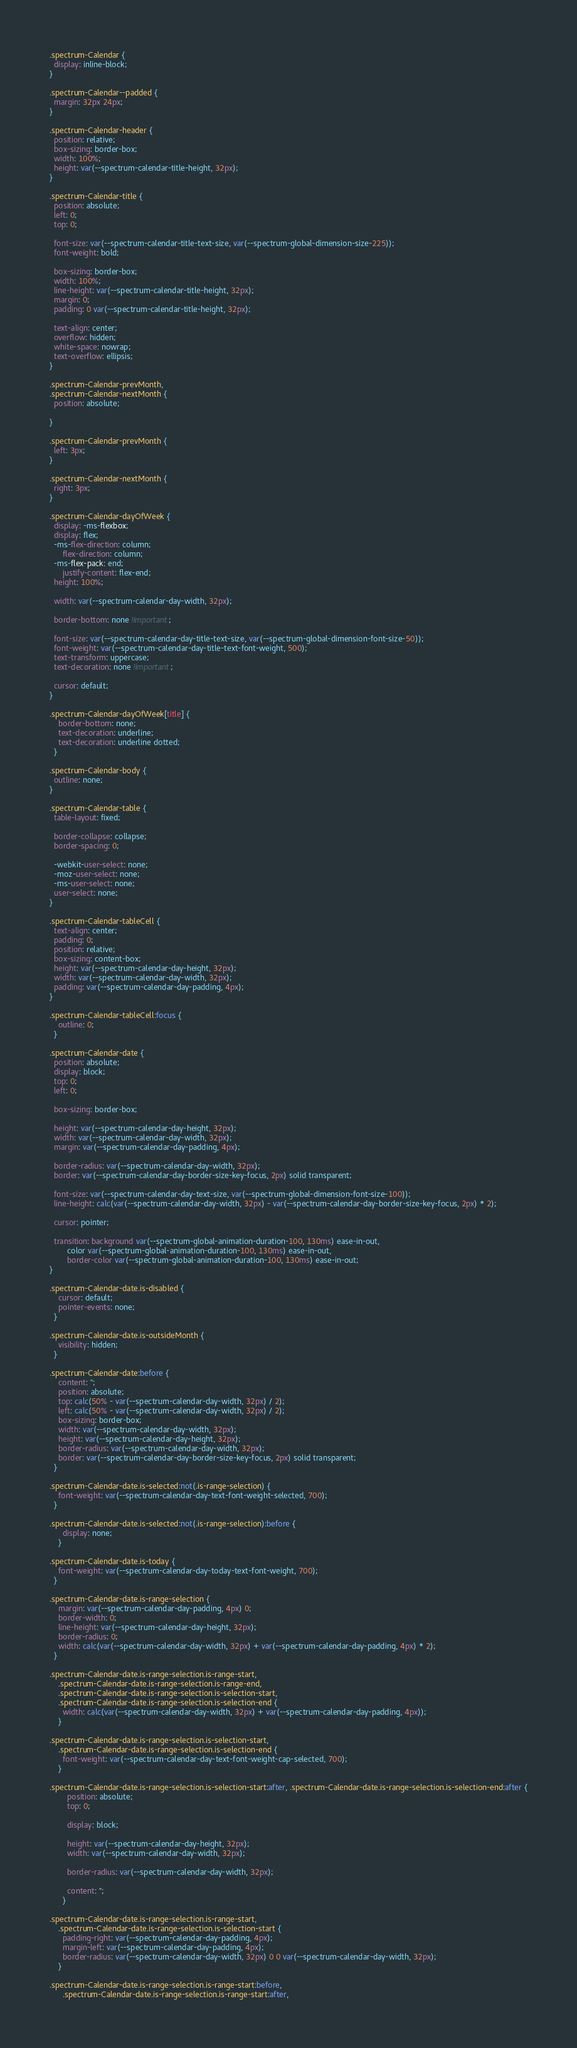<code> <loc_0><loc_0><loc_500><loc_500><_CSS_>.spectrum-Calendar {
  display: inline-block;
}

.spectrum-Calendar--padded {
  margin: 32px 24px;
}

.spectrum-Calendar-header {
  position: relative;
  box-sizing: border-box;
  width: 100%;
  height: var(--spectrum-calendar-title-height, 32px);
}

.spectrum-Calendar-title {
  position: absolute;
  left: 0;
  top: 0;

  font-size: var(--spectrum-calendar-title-text-size, var(--spectrum-global-dimension-size-225));
  font-weight: bold;

  box-sizing: border-box;
  width: 100%;
  line-height: var(--spectrum-calendar-title-height, 32px);
  margin: 0;
  padding: 0 var(--spectrum-calendar-title-height, 32px);

  text-align: center;
  overflow: hidden;
  white-space: nowrap;
  text-overflow: ellipsis;
}

.spectrum-Calendar-prevMonth,
.spectrum-Calendar-nextMonth {
  position: absolute;

}

.spectrum-Calendar-prevMonth {
  left: 3px;
}

.spectrum-Calendar-nextMonth {
  right: 3px;
}

.spectrum-Calendar-dayOfWeek {
  display: -ms-flexbox;
  display: flex;
  -ms-flex-direction: column;
      flex-direction: column;
  -ms-flex-pack: end;
      justify-content: flex-end;
  height: 100%;

  width: var(--spectrum-calendar-day-width, 32px);

  border-bottom: none !important;

  font-size: var(--spectrum-calendar-day-title-text-size, var(--spectrum-global-dimension-font-size-50));
  font-weight: var(--spectrum-calendar-day-title-text-font-weight, 500);
  text-transform: uppercase;
  text-decoration: none !important;

  cursor: default;
}

.spectrum-Calendar-dayOfWeek[title] {
    border-bottom: none;
    text-decoration: underline;
    text-decoration: underline dotted;
  }

.spectrum-Calendar-body {
  outline: none;
}

.spectrum-Calendar-table {
  table-layout: fixed;

  border-collapse: collapse;
  border-spacing: 0;

  -webkit-user-select: none;
  -moz-user-select: none;
  -ms-user-select: none;
  user-select: none;
}

.spectrum-Calendar-tableCell {
  text-align: center;
  padding: 0;
  position: relative;
  box-sizing: content-box;
  height: var(--spectrum-calendar-day-height, 32px);
  width: var(--spectrum-calendar-day-width, 32px);
  padding: var(--spectrum-calendar-day-padding, 4px);
}

.spectrum-Calendar-tableCell:focus {
    outline: 0;
  }

.spectrum-Calendar-date {
  position: absolute;
  display: block;
  top: 0;
  left: 0;

  box-sizing: border-box;

  height: var(--spectrum-calendar-day-height, 32px);
  width: var(--spectrum-calendar-day-width, 32px);
  margin: var(--spectrum-calendar-day-padding, 4px);

  border-radius: var(--spectrum-calendar-day-width, 32px);
  border: var(--spectrum-calendar-day-border-size-key-focus, 2px) solid transparent;

  font-size: var(--spectrum-calendar-day-text-size, var(--spectrum-global-dimension-font-size-100));
  line-height: calc(var(--spectrum-calendar-day-width, 32px) - var(--spectrum-calendar-day-border-size-key-focus, 2px) * 2);

  cursor: pointer;

  transition: background var(--spectrum-global-animation-duration-100, 130ms) ease-in-out,
        color var(--spectrum-global-animation-duration-100, 130ms) ease-in-out,
        border-color var(--spectrum-global-animation-duration-100, 130ms) ease-in-out;
}

.spectrum-Calendar-date.is-disabled {
    cursor: default;
    pointer-events: none;
  }

.spectrum-Calendar-date.is-outsideMonth {
    visibility: hidden;
  }

.spectrum-Calendar-date:before {
    content: '';
    position: absolute;
    top: calc(50% - var(--spectrum-calendar-day-width, 32px) / 2);
    left: calc(50% - var(--spectrum-calendar-day-width, 32px) / 2);
    box-sizing: border-box;
    width: var(--spectrum-calendar-day-width, 32px);
    height: var(--spectrum-calendar-day-height, 32px);
    border-radius: var(--spectrum-calendar-day-width, 32px);
    border: var(--spectrum-calendar-day-border-size-key-focus, 2px) solid transparent;
  }

.spectrum-Calendar-date.is-selected:not(.is-range-selection) {
    font-weight: var(--spectrum-calendar-day-text-font-weight-selected, 700);
  }

.spectrum-Calendar-date.is-selected:not(.is-range-selection):before {
      display: none;
    }

.spectrum-Calendar-date.is-today {
    font-weight: var(--spectrum-calendar-day-today-text-font-weight, 700);
  }

.spectrum-Calendar-date.is-range-selection {
    margin: var(--spectrum-calendar-day-padding, 4px) 0;
    border-width: 0;
    line-height: var(--spectrum-calendar-day-height, 32px);
    border-radius: 0;
    width: calc(var(--spectrum-calendar-day-width, 32px) + var(--spectrum-calendar-day-padding, 4px) * 2);
  }

.spectrum-Calendar-date.is-range-selection.is-range-start,
    .spectrum-Calendar-date.is-range-selection.is-range-end,
    .spectrum-Calendar-date.is-range-selection.is-selection-start,
    .spectrum-Calendar-date.is-range-selection.is-selection-end {
      width: calc(var(--spectrum-calendar-day-width, 32px) + var(--spectrum-calendar-day-padding, 4px));
    }

.spectrum-Calendar-date.is-range-selection.is-selection-start,
    .spectrum-Calendar-date.is-range-selection.is-selection-end {
      font-weight: var(--spectrum-calendar-day-text-font-weight-cap-selected, 700);
    }

.spectrum-Calendar-date.is-range-selection.is-selection-start:after, .spectrum-Calendar-date.is-range-selection.is-selection-end:after {
        position: absolute;
        top: 0;

        display: block;

        height: var(--spectrum-calendar-day-height, 32px);
        width: var(--spectrum-calendar-day-width, 32px);

        border-radius: var(--spectrum-calendar-day-width, 32px);

        content: '';
      }

.spectrum-Calendar-date.is-range-selection.is-range-start,
    .spectrum-Calendar-date.is-range-selection.is-selection-start {
      padding-right: var(--spectrum-calendar-day-padding, 4px);
      margin-left: var(--spectrum-calendar-day-padding, 4px);
      border-radius: var(--spectrum-calendar-day-width, 32px) 0 0 var(--spectrum-calendar-day-width, 32px);
    }

.spectrum-Calendar-date.is-range-selection.is-range-start:before,
      .spectrum-Calendar-date.is-range-selection.is-range-start:after,</code> 